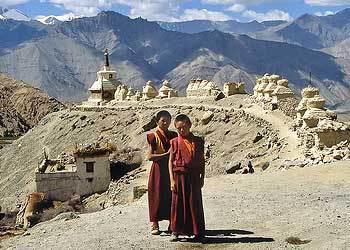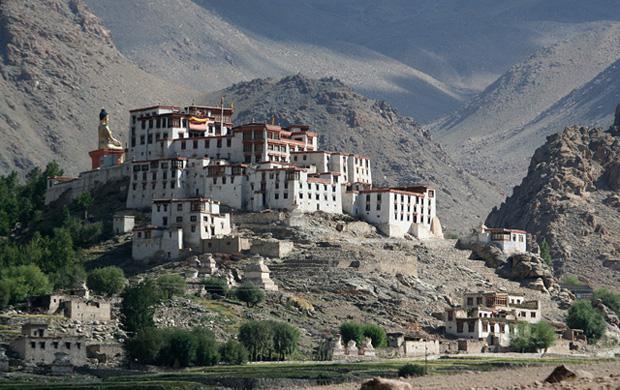The first image is the image on the left, the second image is the image on the right. Evaluate the accuracy of this statement regarding the images: "A statue of a seated human figure is visible amid flat-roofed buildings.". Is it true? Answer yes or no. Yes. 